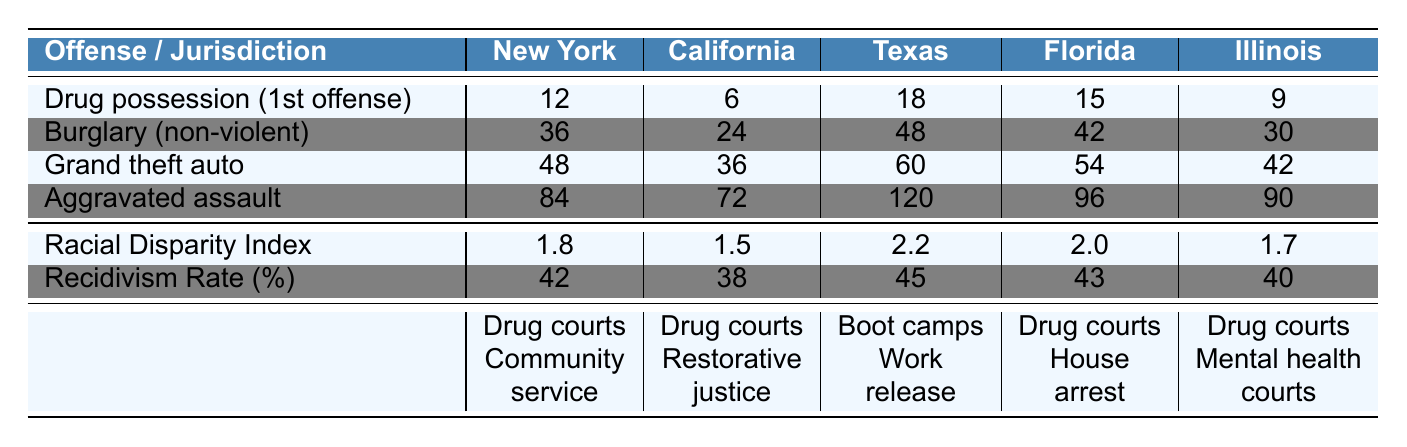What is the longest sentence given for aggravated assault? The table shows the sentence lengths for aggravated assault in each jurisdiction. The longest sentence is from Texas, which has a sentence of 120 months.
Answer: 120 In which jurisdiction is the sentence for drug possession (1st offense) the shortest? The table lists the sentence lengths for drug possession (1st offense) across different jurisdictions. California has the shortest sentence of 6 months.
Answer: California What is the racial disparity index for Florida? The racial disparity index for Florida is listed in the table and is 2.0.
Answer: 2.0 Which jurisdiction has the highest recidivism rate? The recidivism rates are provided for all jurisdictions. Texas has the highest recidivism rate of 45%.
Answer: Texas What is the total sentence length for grand theft auto in New York and California combined? The sentence for grand theft auto in New York is 48 months and in California is 36 months. Adding these together, 48 + 36 = 84 months.
Answer: 84 Is there a jurisdiction where the sentence for burglary (non-violent) is less than the average of all the jurisdictions? The average sentence for burglary (non-violent) can be calculated as (36 + 24 + 48 + 42 + 30) / 5 = 36. There is indeed a jurisdiction, California, with a sentence of 24 months, which is less than the average.
Answer: Yes How many alternative sentencing programs does Illinois have? The table shows that Illinois has three alternative sentencing programs: Drug courts, Mental health courts, and Veteran courts.
Answer: 3 What is the difference in sentence length for aggravated assault between Texas and New York? The sentence for aggravated assault in Texas is 120 months, and in New York, it is 84 months. The difference is 120 - 84 = 36 months.
Answer: 36 Does California have more alternative sentencing programs than New York? California has three alternative sentencing programs (Drug courts, Restorative justice, and Electronic monitoring) while New York has two (Drug courts and Community service). Therefore, California does have more programs.
Answer: Yes What is the average sentence length for drug possession (1st offense) across all jurisdictions? The sentence lengths for drug possession (1st offense) are 12, 6, 18, 15, and 9 months. The average is (12 + 6 + 18 + 15 + 9) / 5 = 12. The average sentence is 12 months.
Answer: 12 